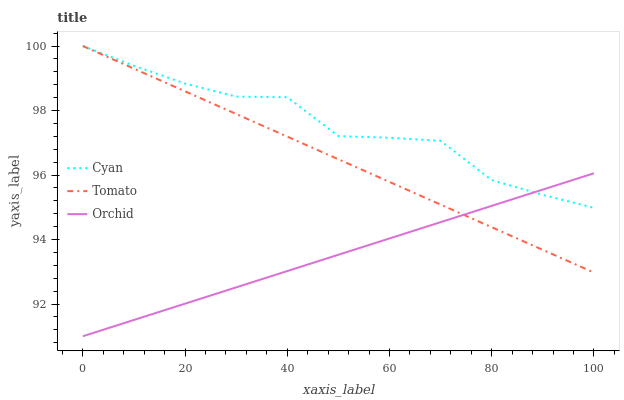Does Orchid have the minimum area under the curve?
Answer yes or no. Yes. Does Cyan have the maximum area under the curve?
Answer yes or no. Yes. Does Cyan have the minimum area under the curve?
Answer yes or no. No. Does Orchid have the maximum area under the curve?
Answer yes or no. No. Is Tomato the smoothest?
Answer yes or no. Yes. Is Cyan the roughest?
Answer yes or no. Yes. Is Orchid the smoothest?
Answer yes or no. No. Is Orchid the roughest?
Answer yes or no. No. Does Orchid have the lowest value?
Answer yes or no. Yes. Does Cyan have the lowest value?
Answer yes or no. No. Does Cyan have the highest value?
Answer yes or no. Yes. Does Orchid have the highest value?
Answer yes or no. No. Does Tomato intersect Orchid?
Answer yes or no. Yes. Is Tomato less than Orchid?
Answer yes or no. No. Is Tomato greater than Orchid?
Answer yes or no. No. 